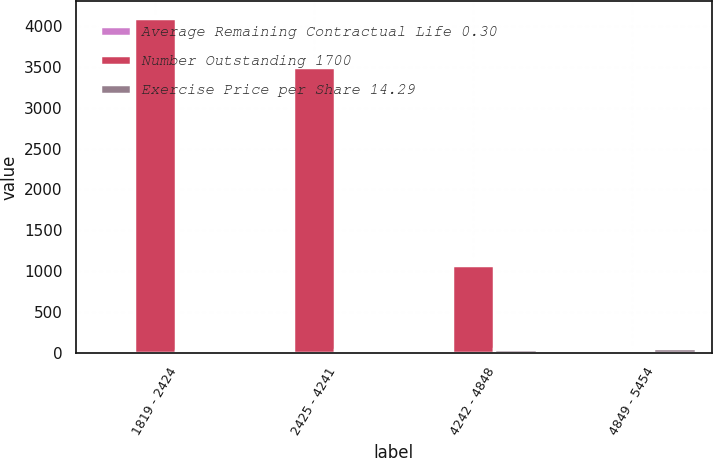Convert chart. <chart><loc_0><loc_0><loc_500><loc_500><stacked_bar_chart><ecel><fcel>1819 - 2424<fcel>2425 - 4241<fcel>4242 - 4848<fcel>4849 - 5454<nl><fcel>Average Remaining Contractual Life 0.30<fcel>0.54<fcel>2.53<fcel>3.12<fcel>3.95<nl><fcel>Number Outstanding 1700<fcel>4100<fcel>3500<fcel>1067<fcel>30.95<nl><fcel>Exercise Price per Share 14.29<fcel>19.15<fcel>30.95<fcel>48.17<fcel>52.25<nl></chart> 